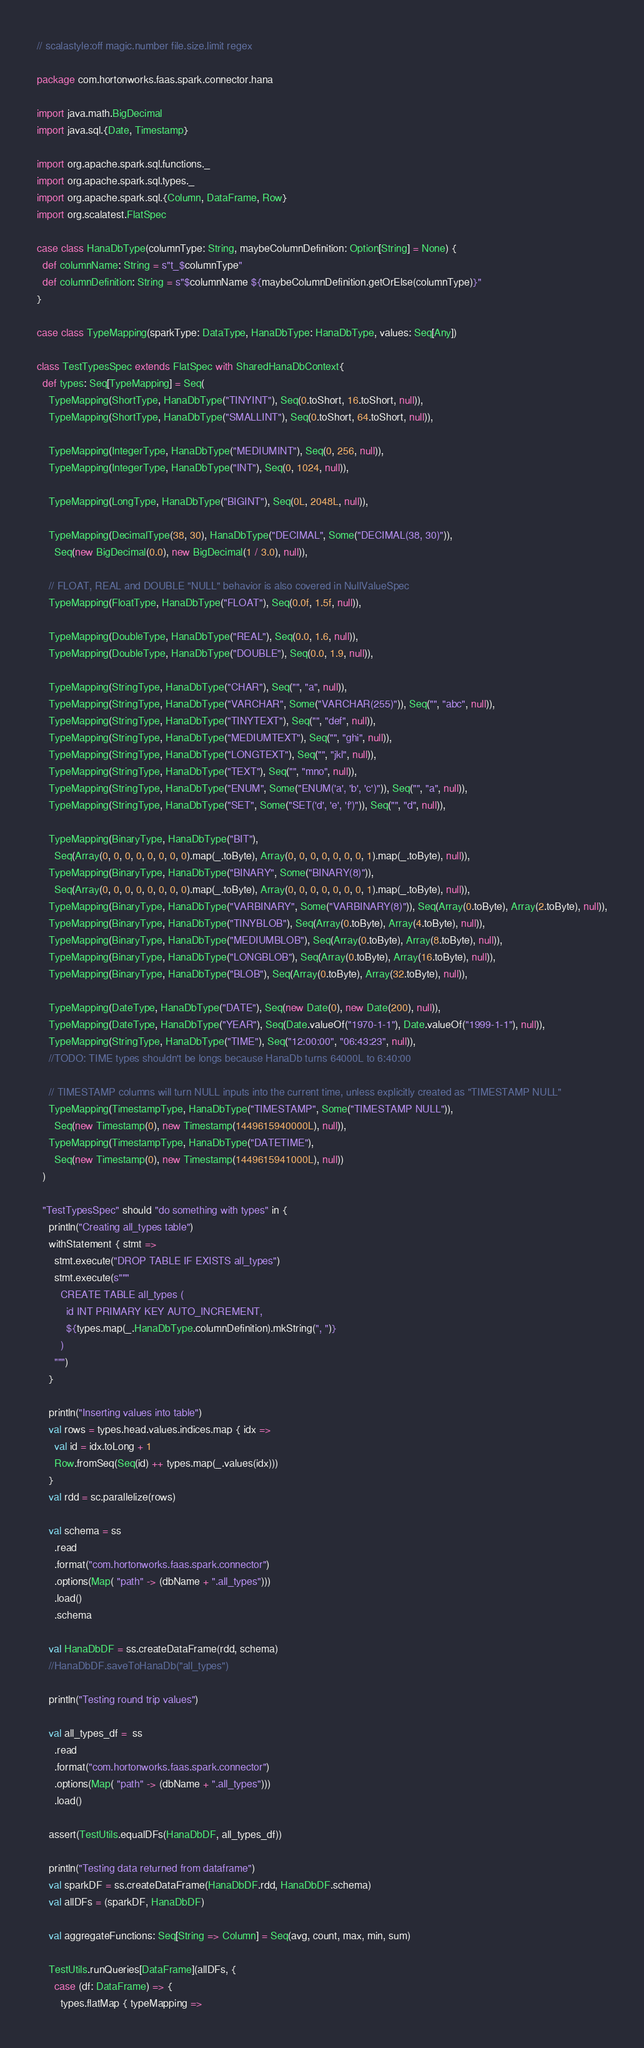Convert code to text. <code><loc_0><loc_0><loc_500><loc_500><_Scala_>// scalastyle:off magic.number file.size.limit regex

package com.hortonworks.faas.spark.connector.hana

import java.math.BigDecimal
import java.sql.{Date, Timestamp}

import org.apache.spark.sql.functions._
import org.apache.spark.sql.types._
import org.apache.spark.sql.{Column, DataFrame, Row}
import org.scalatest.FlatSpec

case class HanaDbType(columnType: String, maybeColumnDefinition: Option[String] = None) {
  def columnName: String = s"t_$columnType"
  def columnDefinition: String = s"$columnName ${maybeColumnDefinition.getOrElse(columnType)}"
}

case class TypeMapping(sparkType: DataType, HanaDbType: HanaDbType, values: Seq[Any])

class TestTypesSpec extends FlatSpec with SharedHanaDbContext{
  def types: Seq[TypeMapping] = Seq(
    TypeMapping(ShortType, HanaDbType("TINYINT"), Seq(0.toShort, 16.toShort, null)),
    TypeMapping(ShortType, HanaDbType("SMALLINT"), Seq(0.toShort, 64.toShort, null)),

    TypeMapping(IntegerType, HanaDbType("MEDIUMINT"), Seq(0, 256, null)),
    TypeMapping(IntegerType, HanaDbType("INT"), Seq(0, 1024, null)),

    TypeMapping(LongType, HanaDbType("BIGINT"), Seq(0L, 2048L, null)),

    TypeMapping(DecimalType(38, 30), HanaDbType("DECIMAL", Some("DECIMAL(38, 30)")),
      Seq(new BigDecimal(0.0), new BigDecimal(1 / 3.0), null)),

    // FLOAT, REAL and DOUBLE "NULL" behavior is also covered in NullValueSpec
    TypeMapping(FloatType, HanaDbType("FLOAT"), Seq(0.0f, 1.5f, null)),

    TypeMapping(DoubleType, HanaDbType("REAL"), Seq(0.0, 1.6, null)),
    TypeMapping(DoubleType, HanaDbType("DOUBLE"), Seq(0.0, 1.9, null)),

    TypeMapping(StringType, HanaDbType("CHAR"), Seq("", "a", null)),
    TypeMapping(StringType, HanaDbType("VARCHAR", Some("VARCHAR(255)")), Seq("", "abc", null)),
    TypeMapping(StringType, HanaDbType("TINYTEXT"), Seq("", "def", null)),
    TypeMapping(StringType, HanaDbType("MEDIUMTEXT"), Seq("", "ghi", null)),
    TypeMapping(StringType, HanaDbType("LONGTEXT"), Seq("", "jkl", null)),
    TypeMapping(StringType, HanaDbType("TEXT"), Seq("", "mno", null)),
    TypeMapping(StringType, HanaDbType("ENUM", Some("ENUM('a', 'b', 'c')")), Seq("", "a", null)),
    TypeMapping(StringType, HanaDbType("SET", Some("SET('d', 'e', 'f')")), Seq("", "d", null)),

    TypeMapping(BinaryType, HanaDbType("BIT"),
      Seq(Array(0, 0, 0, 0, 0, 0, 0, 0).map(_.toByte), Array(0, 0, 0, 0, 0, 0, 0, 1).map(_.toByte), null)),
    TypeMapping(BinaryType, HanaDbType("BINARY", Some("BINARY(8)")),
      Seq(Array(0, 0, 0, 0, 0, 0, 0, 0).map(_.toByte), Array(0, 0, 0, 0, 0, 0, 0, 1).map(_.toByte), null)),
    TypeMapping(BinaryType, HanaDbType("VARBINARY", Some("VARBINARY(8)")), Seq(Array(0.toByte), Array(2.toByte), null)),
    TypeMapping(BinaryType, HanaDbType("TINYBLOB"), Seq(Array(0.toByte), Array(4.toByte), null)),
    TypeMapping(BinaryType, HanaDbType("MEDIUMBLOB"), Seq(Array(0.toByte), Array(8.toByte), null)),
    TypeMapping(BinaryType, HanaDbType("LONGBLOB"), Seq(Array(0.toByte), Array(16.toByte), null)),
    TypeMapping(BinaryType, HanaDbType("BLOB"), Seq(Array(0.toByte), Array(32.toByte), null)),

    TypeMapping(DateType, HanaDbType("DATE"), Seq(new Date(0), new Date(200), null)),
    TypeMapping(DateType, HanaDbType("YEAR"), Seq(Date.valueOf("1970-1-1"), Date.valueOf("1999-1-1"), null)),
    TypeMapping(StringType, HanaDbType("TIME"), Seq("12:00:00", "06:43:23", null)),
    //TODO: TIME types shouldn't be longs because HanaDb turns 64000L to 6:40:00

    // TIMESTAMP columns will turn NULL inputs into the current time, unless explicitly created as "TIMESTAMP NULL"
    TypeMapping(TimestampType, HanaDbType("TIMESTAMP", Some("TIMESTAMP NULL")),
      Seq(new Timestamp(0), new Timestamp(1449615940000L), null)),
    TypeMapping(TimestampType, HanaDbType("DATETIME"),
      Seq(new Timestamp(0), new Timestamp(1449615941000L), null))
  )

  "TestTypesSpec" should "do something with types" in {
    println("Creating all_types table")
    withStatement { stmt =>
      stmt.execute("DROP TABLE IF EXISTS all_types")
      stmt.execute(s"""
        CREATE TABLE all_types (
          id INT PRIMARY KEY AUTO_INCREMENT,
          ${types.map(_.HanaDbType.columnDefinition).mkString(", ")}
        )
      """)
    }

    println("Inserting values into table")
    val rows = types.head.values.indices.map { idx =>
      val id = idx.toLong + 1
      Row.fromSeq(Seq(id) ++ types.map(_.values(idx)))
    }
    val rdd = sc.parallelize(rows)

    val schema = ss
      .read
      .format("com.hortonworks.faas.spark.connector")
      .options(Map( "path" -> (dbName + ".all_types")))
      .load()
      .schema

    val HanaDbDF = ss.createDataFrame(rdd, schema)
    //HanaDbDF.saveToHanaDb("all_types")

    println("Testing round trip values")

    val all_types_df =  ss
      .read
      .format("com.hortonworks.faas.spark.connector")
      .options(Map( "path" -> (dbName + ".all_types")))
      .load()

    assert(TestUtils.equalDFs(HanaDbDF, all_types_df))

    println("Testing data returned from dataframe")
    val sparkDF = ss.createDataFrame(HanaDbDF.rdd, HanaDbDF.schema)
    val allDFs = (sparkDF, HanaDbDF)

    val aggregateFunctions: Seq[String => Column] = Seq(avg, count, max, min, sum)

    TestUtils.runQueries[DataFrame](allDFs, {
      case (df: DataFrame) => {
        types.flatMap { typeMapping =></code> 